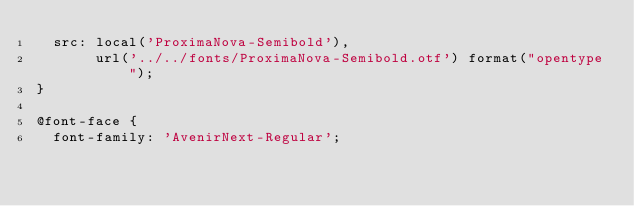<code> <loc_0><loc_0><loc_500><loc_500><_CSS_>  src: local('ProximaNova-Semibold'),
       url('../../fonts/ProximaNova-Semibold.otf') format("opentype");
}

@font-face {
  font-family: 'AvenirNext-Regular';</code> 